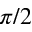<formula> <loc_0><loc_0><loc_500><loc_500>\pi / 2</formula> 